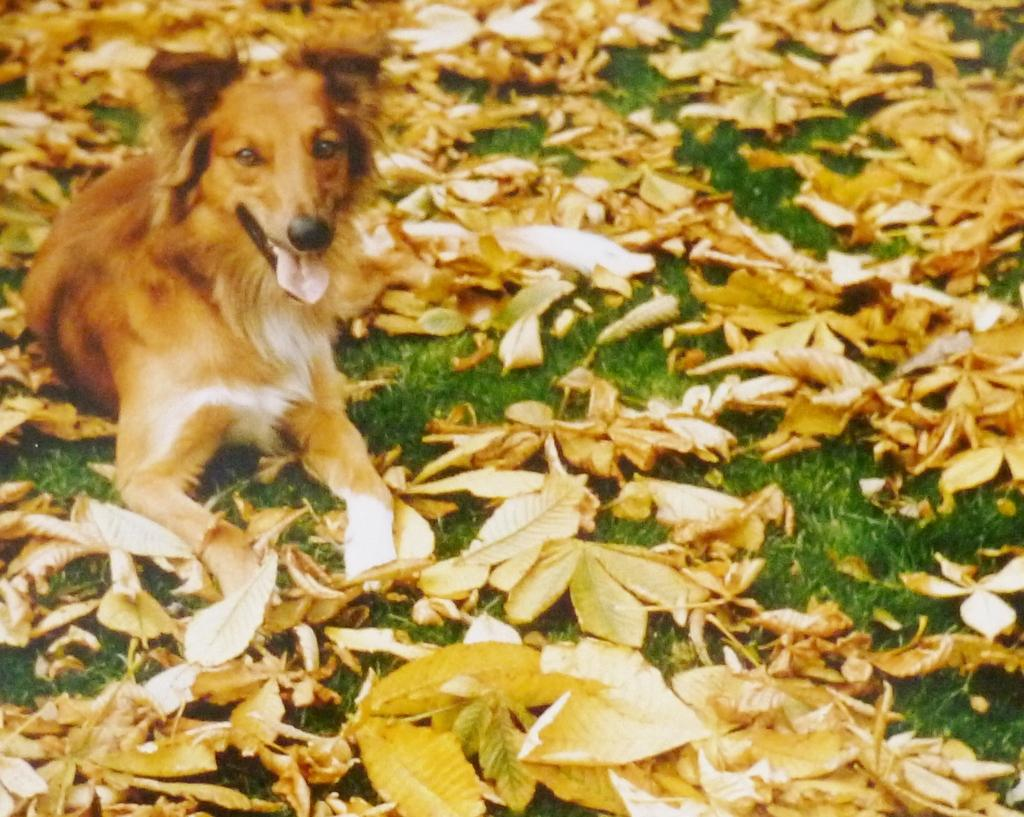What is covering the ground in the image? There are dry leaves on the ground in the image. What type of vegetation is present in the image? There is grass in the image. Where is the dog located in the image? The dog is on the left side of the image. What type of slave is depicted in the image? There is no slave present in the image; it features dry leaves, grass, and a dog. How does the dog's nervous system function in the image? The image does not provide information about the dog's nervous system or its functioning. 